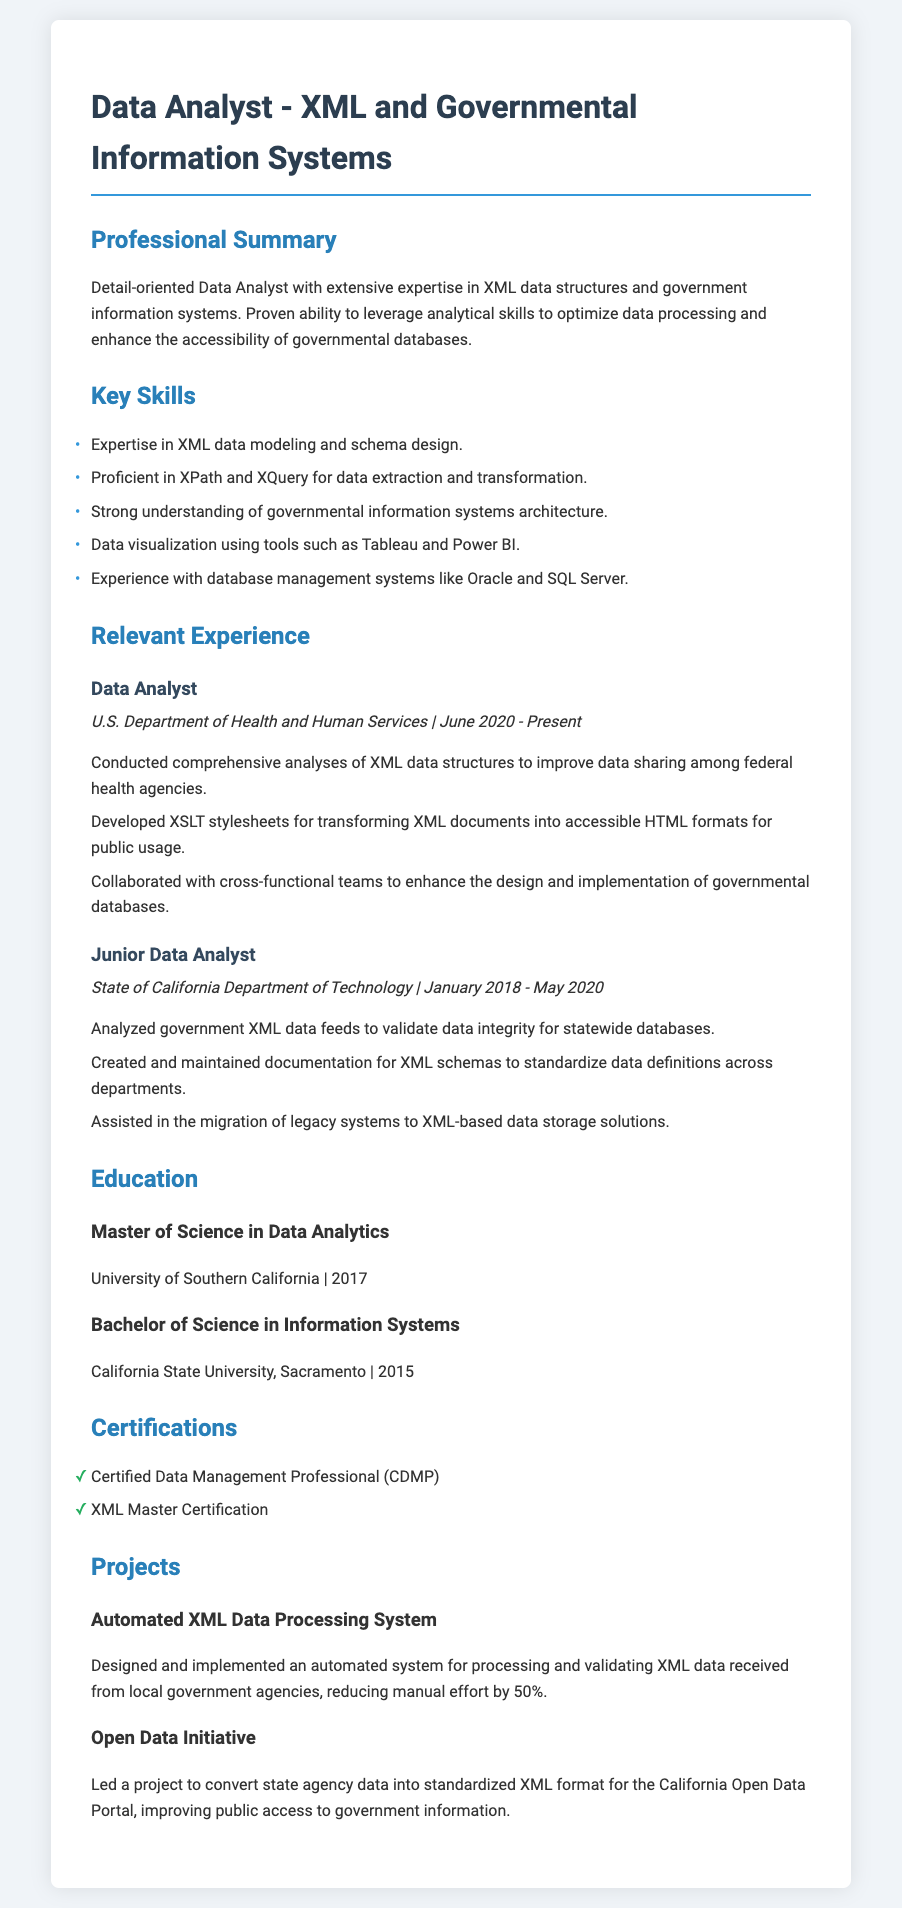What is the role of the data analyst? The position held is clearly stated in the document under the Professional Summary section.
Answer: Data Analyst Which governmental department is mentioned in the most recent experience? The document lists the U.S. Department of Health and Human Services as the place of employment in the current role.
Answer: U.S. Department of Health and Human Services What is the duration of employment in the current position? The employment duration is specified as starting from June 2020 to the present.
Answer: June 2020 - Present What degree was obtained in 2017? The education section lists the Master of Science in Data Analytics as the degree earned in that year.
Answer: Master of Science in Data Analytics What is one tool used for data visualization mentioned in the resume? The Key Skills section specifies various tools, including Tableau.
Answer: Tableau How many certifications are listed in the document? The document explicitly states that there are two certifications mentioned.
Answer: 2 What type of project was implemented to reduce manual effort by 50%? The Projects section details an Automated XML Data Processing System designed for this purpose.
Answer: Automated XML Data Processing System What is the main focus of the Open Data Initiative project? The project aimed to convert state agency data into a standardized format, as detailed in the Projects section.
Answer: Standardized XML format In which year was the Bachelor's degree completed? The education section specifies the year of completion for the Bachelor's degree as 2015.
Answer: 2015 